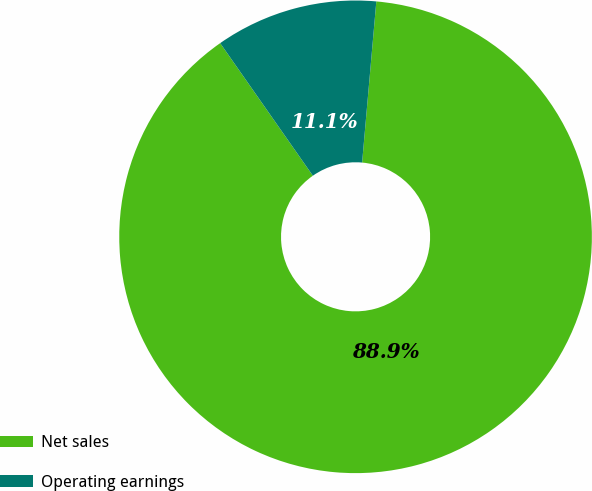<chart> <loc_0><loc_0><loc_500><loc_500><pie_chart><fcel>Net sales<fcel>Operating earnings<nl><fcel>88.89%<fcel>11.11%<nl></chart> 